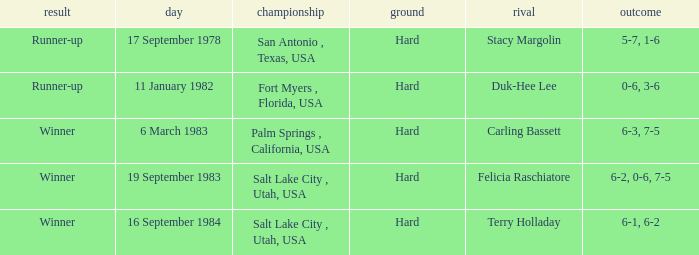Who was the opponent for the match were the outcome was runner-up and the score was 5-7, 1-6? Stacy Margolin. 